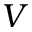<formula> <loc_0><loc_0><loc_500><loc_500>V</formula> 